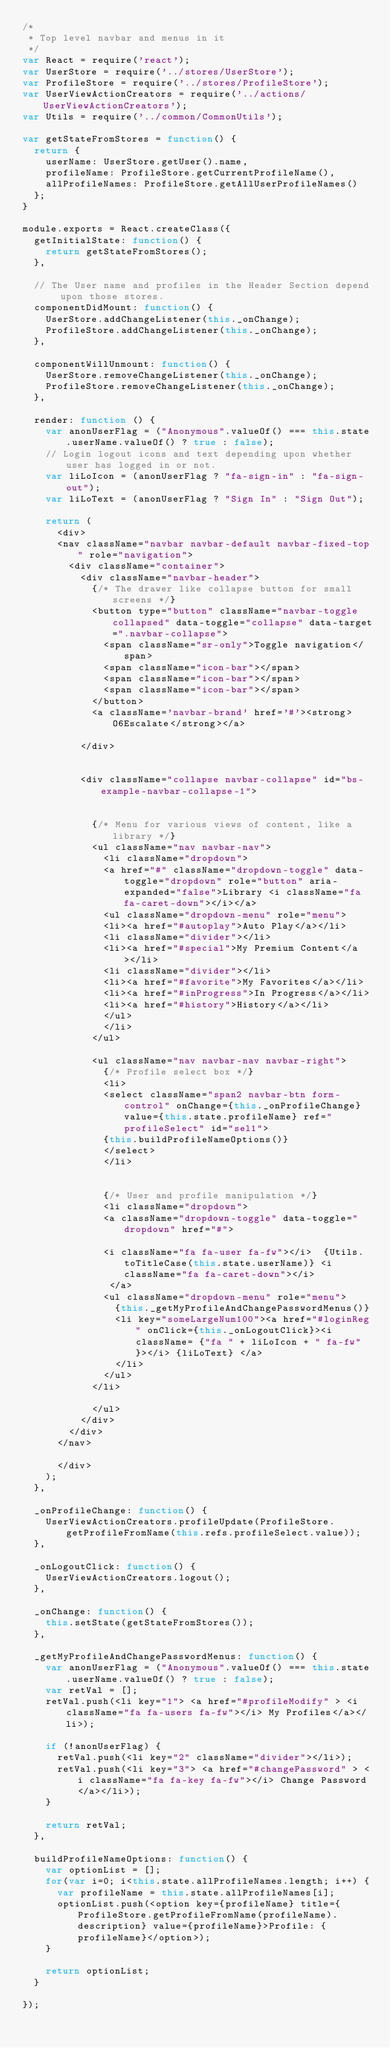Convert code to text. <code><loc_0><loc_0><loc_500><loc_500><_JavaScript_>/*
 * Top level navbar and menus in it
 */
var React = require('react');
var UserStore = require('../stores/UserStore');
var ProfileStore = require('../stores/ProfileStore');
var UserViewActionCreators = require('../actions/UserViewActionCreators');
var Utils = require('../common/CommonUtils');

var getStateFromStores = function() {
  return {
    userName: UserStore.getUser().name,
    profileName: ProfileStore.getCurrentProfileName(),
    allProfileNames: ProfileStore.getAllUserProfileNames()
  };
}

module.exports = React.createClass({
  getInitialState: function() {
    return getStateFromStores();
  },
  
  // The User name and profiles in the Header Section depend upon those stores.
  componentDidMount: function() {
    UserStore.addChangeListener(this._onChange);
    ProfileStore.addChangeListener(this._onChange);
  },

  componentWillUnmount: function() {
    UserStore.removeChangeListener(this._onChange);
    ProfileStore.removeChangeListener(this._onChange);
  },
  
  render: function () {
    var anonUserFlag = ("Anonymous".valueOf() === this.state.userName.valueOf() ? true : false);
    // Login logout icons and text depending upon whether user has logged in or not.
    var liLoIcon = (anonUserFlag ? "fa-sign-in" : "fa-sign-out");
    var liLoText = (anonUserFlag ? "Sign In" : "Sign Out");
    
    return (
      <div>
      <nav className="navbar navbar-default navbar-fixed-top" role="navigation">
      	<div className="container">
          <div className="navbar-header">
            {/* The drawer like collapse button for small screens */}
            <button type="button" className="navbar-toggle collapsed" data-toggle="collapse" data-target=".navbar-collapse">
              <span className="sr-only">Toggle navigation</span>
              <span className="icon-bar"></span>
              <span className="icon-bar"></span>
              <span className="icon-bar"></span>
            </button>
            <a className='navbar-brand' href='#'><strong>O6Escalate</strong></a>
            
          </div>


          <div className="collapse navbar-collapse" id="bs-example-navbar-collapse-1">
          

            {/* Menu for various views of content, like a library */}
            <ul className="nav navbar-nav">
              <li className="dropdown">
              <a href="#" className="dropdown-toggle" data-toggle="dropdown" role="button" aria-expanded="false">Library <i className="fa fa-caret-down"></i></a>
              <ul className="dropdown-menu" role="menu">
              <li><a href="#autoplay">Auto Play</a></li>
              <li className="divider"></li>
              <li><a href="#special">My Premium Content</a></li>
              <li className="divider"></li>
              <li><a href="#favorite">My Favorites</a></li>
              <li><a href="#inProgress">In Progress</a></li>
              <li><a href="#history">History</a></li>
              </ul>
              </li>
            </ul>
            
            <ul className="nav navbar-nav navbar-right">
              {/* Profile select box */}
              <li>
              <select className="span2 navbar-btn form-control" onChange={this._onProfileChange} value={this.state.profileName} ref="profileSelect" id="sel1">
              {this.buildProfileNameOptions()}
              </select>
              </li>
              
              
              {/* User and profile manipulation */}
              <li className="dropdown">
              <a className="dropdown-toggle" data-toggle="dropdown" href="#">
              
              <i className="fa fa-user fa-fw"></i>  {Utils.toTitleCase(this.state.userName)} <i className="fa fa-caret-down"></i>
               </a>
              <ul className="dropdown-menu" role="menu">
                {this._getMyProfileAndChangePasswordMenus()}
                <li key="someLargeNum100"><a href="#loginReg" onClick={this._onLogoutClick}><i className= {"fa " + liLoIcon + " fa-fw"}></i> {liLoText} </a>
                </li>
              </ul>
            </li>
            
            </ul>            
          </div>
        </div>
      </nav>
      
      </div>
    );
  },
  
  _onProfileChange: function() {
    UserViewActionCreators.profileUpdate(ProfileStore.getProfileFromName(this.refs.profileSelect.value));
  },

  _onLogoutClick: function() {
    UserViewActionCreators.logout();
  },

  _onChange: function() {
    this.setState(getStateFromStores());
  },
  
  _getMyProfileAndChangePasswordMenus: function() {
    var anonUserFlag = ("Anonymous".valueOf() === this.state.userName.valueOf() ? true : false);
    var retVal = [];
    retVal.push(<li key="1"> <a href="#profileModify" > <i className="fa fa-users fa-fw"></i> My Profiles</a></li>);

    if (!anonUserFlag) {
      retVal.push(<li key="2" className="divider"></li>);
      retVal.push(<li key="3"> <a href="#changePassword" > <i className="fa fa-key fa-fw"></i> Change Password </a></li>);
    }
    
    return retVal;
  },
  
  buildProfileNameOptions: function() {
    var optionList = [];
    for(var i=0; i<this.state.allProfileNames.length; i++) {
      var profileName = this.state.allProfileNames[i];
      optionList.push(<option key={profileName} title={ProfileStore.getProfileFromName(profileName).description} value={profileName}>Profile: {profileName}</option>);
    }
    
    return optionList;
  }

});

</code> 